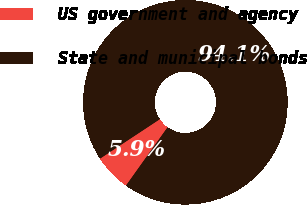Convert chart to OTSL. <chart><loc_0><loc_0><loc_500><loc_500><pie_chart><fcel>US government and agency<fcel>State and municipal bonds<nl><fcel>5.86%<fcel>94.14%<nl></chart> 